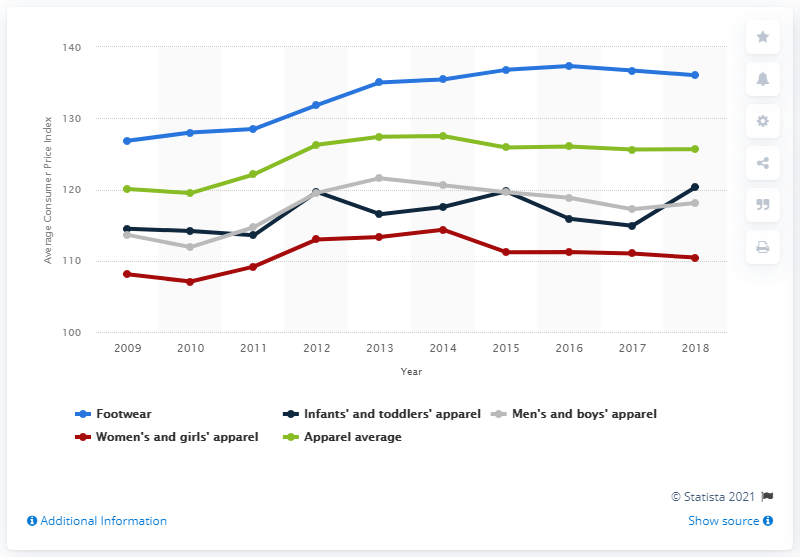Outline some significant characteristics in this image. The Consumer Price Index for infants and toddlers' apparel in 2018 was 120.32. 